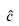Convert formula to latex. <formula><loc_0><loc_0><loc_500><loc_500>\hat { c }</formula> 